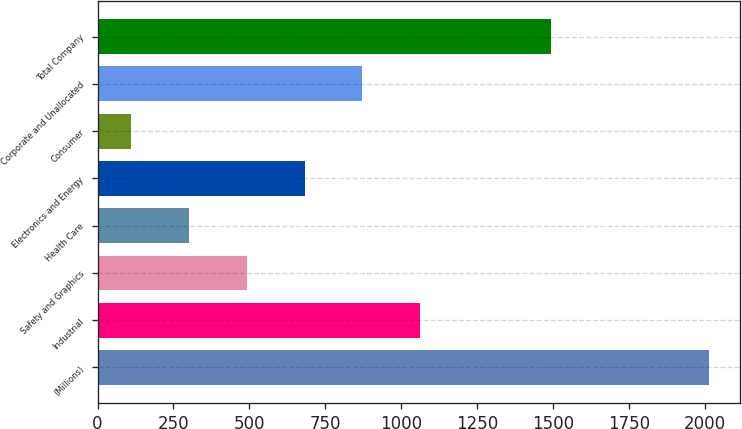<chart> <loc_0><loc_0><loc_500><loc_500><bar_chart><fcel>(Millions)<fcel>Industrial<fcel>Safety and Graphics<fcel>Health Care<fcel>Electronics and Energy<fcel>Consumer<fcel>Corporate and Unallocated<fcel>Total Company<nl><fcel>2014<fcel>1062.5<fcel>491.6<fcel>301.3<fcel>681.9<fcel>111<fcel>872.2<fcel>1493<nl></chart> 